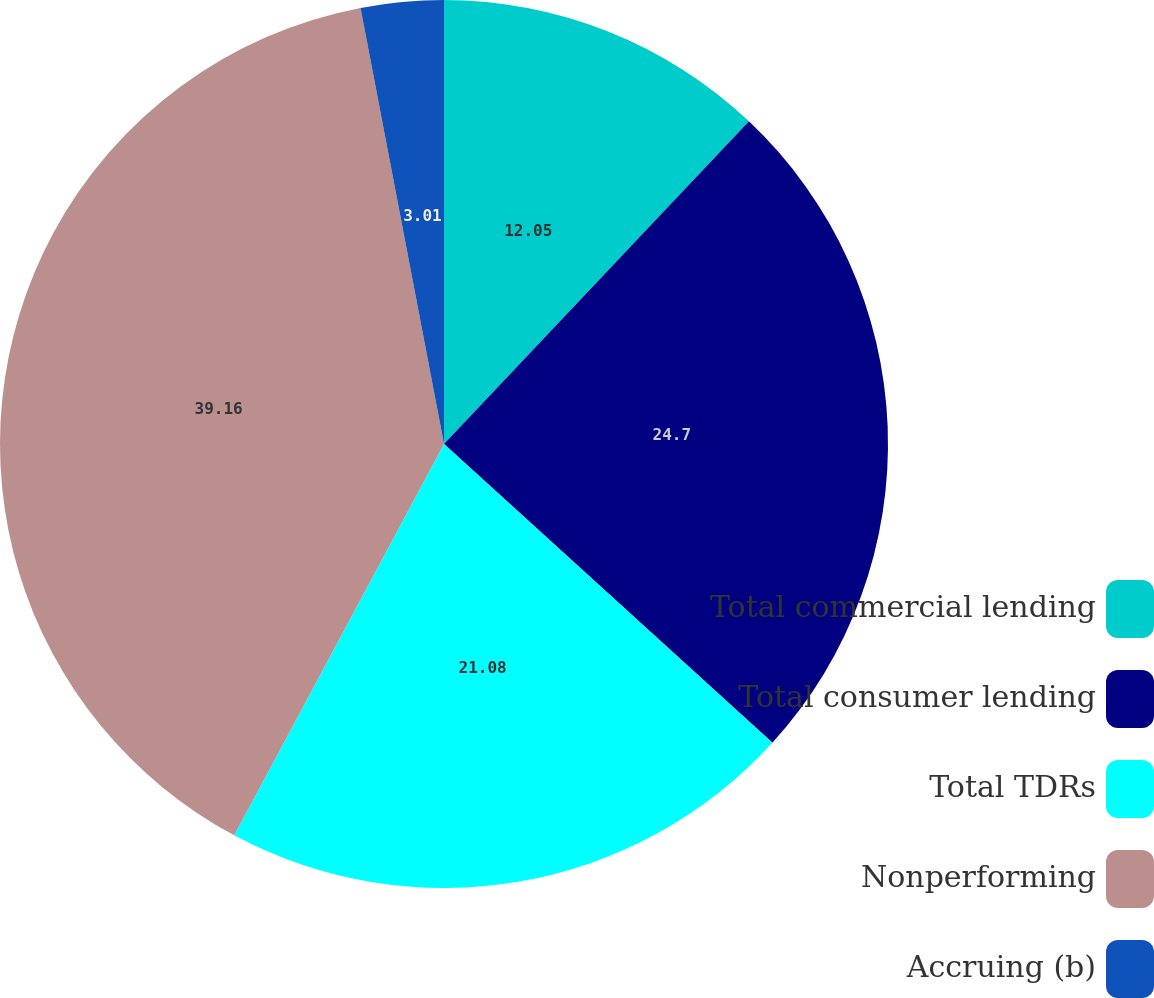<chart> <loc_0><loc_0><loc_500><loc_500><pie_chart><fcel>Total commercial lending<fcel>Total consumer lending<fcel>Total TDRs<fcel>Nonperforming<fcel>Accruing (b)<nl><fcel>12.05%<fcel>24.7%<fcel>21.08%<fcel>39.16%<fcel>3.01%<nl></chart> 